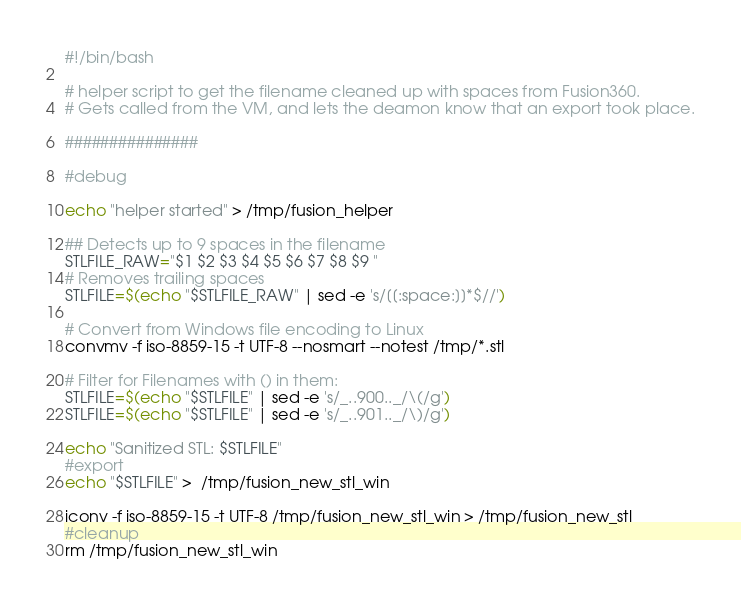Convert code to text. <code><loc_0><loc_0><loc_500><loc_500><_Bash_>#!/bin/bash

# helper script to get the filename cleaned up with spaces from Fusion360.
# Gets called from the VM, and lets the deamon know that an export took place.

###############

#debug 

echo "helper started" > /tmp/fusion_helper

## Detects up to 9 spaces in the filename
STLFILE_RAW="$1 $2 $3 $4 $5 $6 $7 $8 $9 "
# Removes trailing spaces
STLFILE=$(echo "$STLFILE_RAW" | sed -e 's/[[:space:]]*$//')

# Convert from Windows file encoding to Linux
convmv -f iso-8859-15 -t UTF-8 --nosmart --notest /tmp/*.stl

# Filter for Filenames with () in them:
STLFILE=$(echo "$STLFILE" | sed -e 's/_..900.._/\(/g')
STLFILE=$(echo "$STLFILE" | sed -e 's/_..901.._/\)/g')

echo "Sanitized STL: $STLFILE"
#export
echo "$STLFILE" >  /tmp/fusion_new_stl_win

iconv -f iso-8859-15 -t UTF-8 /tmp/fusion_new_stl_win > /tmp/fusion_new_stl
#cleanup
rm /tmp/fusion_new_stl_win

</code> 